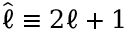<formula> <loc_0><loc_0><loc_500><loc_500>{ \hat { \ell } \equiv 2 \ell + 1 }</formula> 